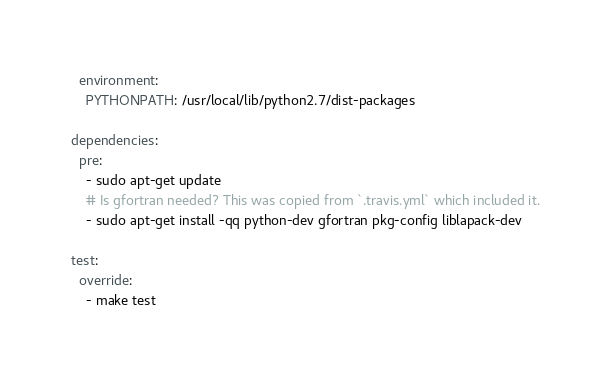<code> <loc_0><loc_0><loc_500><loc_500><_YAML_>  environment:
    PYTHONPATH: /usr/local/lib/python2.7/dist-packages

dependencies:
  pre:
    - sudo apt-get update
    # Is gfortran needed? This was copied from `.travis.yml` which included it.
    - sudo apt-get install -qq python-dev gfortran pkg-config liblapack-dev

test:
  override:
    - make test
</code> 